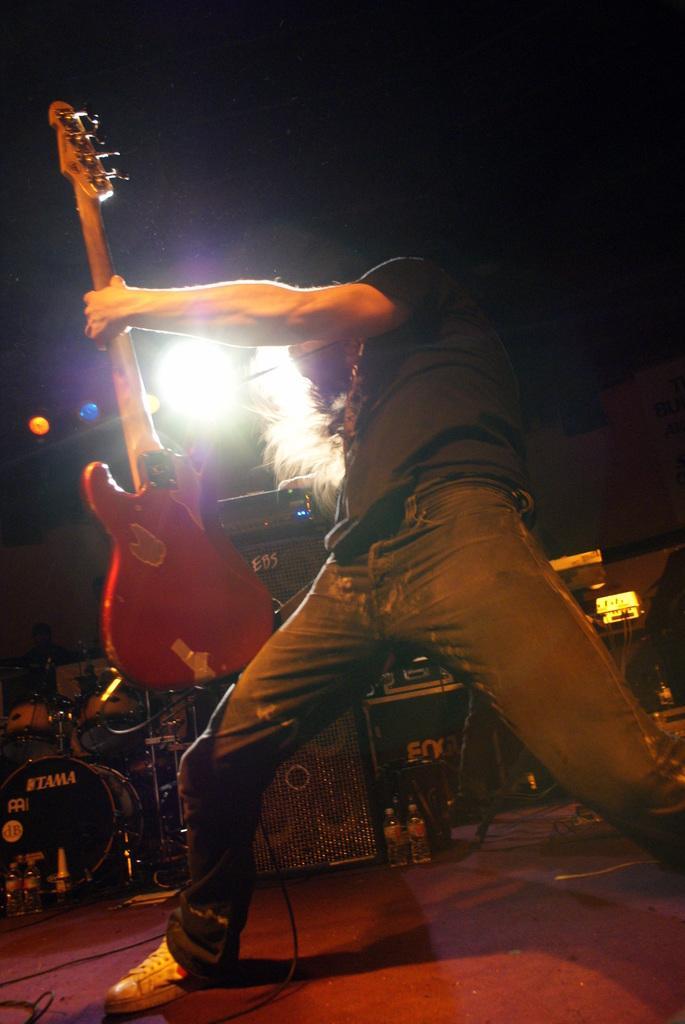Describe this image in one or two sentences. This person is standing and holding a guitar. On top there are focusing lights. These are musical instruments. This is speaker. 